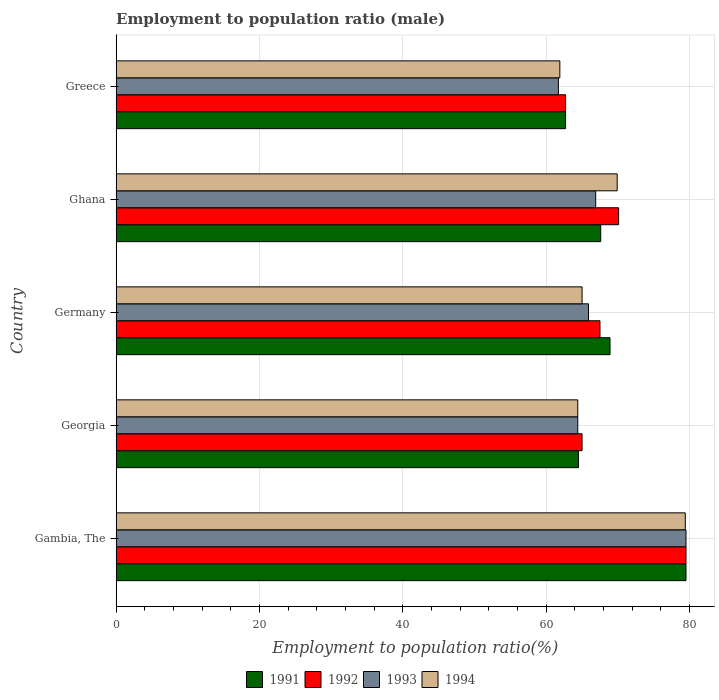How many groups of bars are there?
Your answer should be very brief. 5. Are the number of bars on each tick of the Y-axis equal?
Your answer should be very brief. Yes. How many bars are there on the 2nd tick from the top?
Offer a very short reply. 4. How many bars are there on the 1st tick from the bottom?
Ensure brevity in your answer.  4. In how many cases, is the number of bars for a given country not equal to the number of legend labels?
Keep it short and to the point. 0. What is the employment to population ratio in 1993 in Georgia?
Offer a very short reply. 64.4. Across all countries, what is the maximum employment to population ratio in 1993?
Give a very brief answer. 79.5. Across all countries, what is the minimum employment to population ratio in 1991?
Ensure brevity in your answer.  62.7. In which country was the employment to population ratio in 1991 maximum?
Offer a terse response. Gambia, The. In which country was the employment to population ratio in 1992 minimum?
Offer a very short reply. Greece. What is the total employment to population ratio in 1991 in the graph?
Your response must be concise. 343.2. What is the difference between the employment to population ratio in 1991 in Georgia and that in Germany?
Provide a short and direct response. -4.4. What is the difference between the employment to population ratio in 1993 in Georgia and the employment to population ratio in 1991 in Greece?
Your answer should be very brief. 1.7. What is the average employment to population ratio in 1992 per country?
Keep it short and to the point. 68.96. What is the difference between the employment to population ratio in 1992 and employment to population ratio in 1991 in Gambia, The?
Your response must be concise. 0. What is the ratio of the employment to population ratio in 1993 in Gambia, The to that in Germany?
Provide a short and direct response. 1.21. What is the difference between the highest and the second highest employment to population ratio in 1993?
Provide a short and direct response. 12.6. What is the difference between the highest and the lowest employment to population ratio in 1993?
Your answer should be very brief. 17.8. Is it the case that in every country, the sum of the employment to population ratio in 1993 and employment to population ratio in 1992 is greater than the sum of employment to population ratio in 1994 and employment to population ratio in 1991?
Offer a terse response. No. What does the 1st bar from the top in Gambia, The represents?
Offer a very short reply. 1994. Is it the case that in every country, the sum of the employment to population ratio in 1994 and employment to population ratio in 1992 is greater than the employment to population ratio in 1993?
Keep it short and to the point. Yes. Are all the bars in the graph horizontal?
Your answer should be very brief. Yes. How many countries are there in the graph?
Provide a short and direct response. 5. Are the values on the major ticks of X-axis written in scientific E-notation?
Provide a succinct answer. No. Does the graph contain any zero values?
Your answer should be very brief. No. Does the graph contain grids?
Make the answer very short. Yes. How many legend labels are there?
Give a very brief answer. 4. What is the title of the graph?
Offer a very short reply. Employment to population ratio (male). What is the label or title of the Y-axis?
Give a very brief answer. Country. What is the Employment to population ratio(%) of 1991 in Gambia, The?
Offer a terse response. 79.5. What is the Employment to population ratio(%) of 1992 in Gambia, The?
Provide a short and direct response. 79.5. What is the Employment to population ratio(%) in 1993 in Gambia, The?
Your answer should be compact. 79.5. What is the Employment to population ratio(%) of 1994 in Gambia, The?
Your answer should be compact. 79.4. What is the Employment to population ratio(%) in 1991 in Georgia?
Provide a succinct answer. 64.5. What is the Employment to population ratio(%) in 1992 in Georgia?
Offer a terse response. 65. What is the Employment to population ratio(%) of 1993 in Georgia?
Give a very brief answer. 64.4. What is the Employment to population ratio(%) in 1994 in Georgia?
Offer a terse response. 64.4. What is the Employment to population ratio(%) in 1991 in Germany?
Provide a short and direct response. 68.9. What is the Employment to population ratio(%) in 1992 in Germany?
Your response must be concise. 67.5. What is the Employment to population ratio(%) of 1993 in Germany?
Offer a terse response. 65.9. What is the Employment to population ratio(%) in 1994 in Germany?
Offer a very short reply. 65. What is the Employment to population ratio(%) of 1991 in Ghana?
Make the answer very short. 67.6. What is the Employment to population ratio(%) in 1992 in Ghana?
Offer a very short reply. 70.1. What is the Employment to population ratio(%) of 1993 in Ghana?
Your answer should be very brief. 66.9. What is the Employment to population ratio(%) in 1994 in Ghana?
Your response must be concise. 69.9. What is the Employment to population ratio(%) of 1991 in Greece?
Your response must be concise. 62.7. What is the Employment to population ratio(%) of 1992 in Greece?
Your answer should be very brief. 62.7. What is the Employment to population ratio(%) of 1993 in Greece?
Give a very brief answer. 61.7. What is the Employment to population ratio(%) of 1994 in Greece?
Your answer should be very brief. 61.9. Across all countries, what is the maximum Employment to population ratio(%) in 1991?
Ensure brevity in your answer.  79.5. Across all countries, what is the maximum Employment to population ratio(%) in 1992?
Your answer should be very brief. 79.5. Across all countries, what is the maximum Employment to population ratio(%) in 1993?
Keep it short and to the point. 79.5. Across all countries, what is the maximum Employment to population ratio(%) in 1994?
Your response must be concise. 79.4. Across all countries, what is the minimum Employment to population ratio(%) in 1991?
Give a very brief answer. 62.7. Across all countries, what is the minimum Employment to population ratio(%) of 1992?
Offer a very short reply. 62.7. Across all countries, what is the minimum Employment to population ratio(%) of 1993?
Keep it short and to the point. 61.7. Across all countries, what is the minimum Employment to population ratio(%) in 1994?
Keep it short and to the point. 61.9. What is the total Employment to population ratio(%) in 1991 in the graph?
Your answer should be compact. 343.2. What is the total Employment to population ratio(%) in 1992 in the graph?
Your answer should be compact. 344.8. What is the total Employment to population ratio(%) of 1993 in the graph?
Ensure brevity in your answer.  338.4. What is the total Employment to population ratio(%) in 1994 in the graph?
Keep it short and to the point. 340.6. What is the difference between the Employment to population ratio(%) of 1992 in Gambia, The and that in Georgia?
Your answer should be very brief. 14.5. What is the difference between the Employment to population ratio(%) of 1993 in Gambia, The and that in Georgia?
Offer a very short reply. 15.1. What is the difference between the Employment to population ratio(%) of 1991 in Gambia, The and that in Germany?
Make the answer very short. 10.6. What is the difference between the Employment to population ratio(%) of 1992 in Gambia, The and that in Germany?
Offer a very short reply. 12. What is the difference between the Employment to population ratio(%) of 1991 in Gambia, The and that in Ghana?
Provide a succinct answer. 11.9. What is the difference between the Employment to population ratio(%) of 1992 in Gambia, The and that in Ghana?
Ensure brevity in your answer.  9.4. What is the difference between the Employment to population ratio(%) of 1993 in Gambia, The and that in Greece?
Your response must be concise. 17.8. What is the difference between the Employment to population ratio(%) of 1991 in Georgia and that in Germany?
Make the answer very short. -4.4. What is the difference between the Employment to population ratio(%) of 1992 in Georgia and that in Germany?
Your answer should be very brief. -2.5. What is the difference between the Employment to population ratio(%) in 1993 in Georgia and that in Germany?
Make the answer very short. -1.5. What is the difference between the Employment to population ratio(%) in 1994 in Georgia and that in Germany?
Your response must be concise. -0.6. What is the difference between the Employment to population ratio(%) of 1992 in Georgia and that in Ghana?
Offer a very short reply. -5.1. What is the difference between the Employment to population ratio(%) in 1994 in Georgia and that in Ghana?
Offer a terse response. -5.5. What is the difference between the Employment to population ratio(%) in 1992 in Georgia and that in Greece?
Make the answer very short. 2.3. What is the difference between the Employment to population ratio(%) in 1994 in Georgia and that in Greece?
Give a very brief answer. 2.5. What is the difference between the Employment to population ratio(%) of 1991 in Germany and that in Ghana?
Provide a succinct answer. 1.3. What is the difference between the Employment to population ratio(%) of 1992 in Germany and that in Ghana?
Your answer should be very brief. -2.6. What is the difference between the Employment to population ratio(%) in 1992 in Germany and that in Greece?
Provide a short and direct response. 4.8. What is the difference between the Employment to population ratio(%) of 1993 in Germany and that in Greece?
Provide a succinct answer. 4.2. What is the difference between the Employment to population ratio(%) of 1994 in Germany and that in Greece?
Provide a succinct answer. 3.1. What is the difference between the Employment to population ratio(%) in 1992 in Ghana and that in Greece?
Provide a short and direct response. 7.4. What is the difference between the Employment to population ratio(%) of 1993 in Ghana and that in Greece?
Give a very brief answer. 5.2. What is the difference between the Employment to population ratio(%) of 1994 in Ghana and that in Greece?
Provide a succinct answer. 8. What is the difference between the Employment to population ratio(%) in 1991 in Gambia, The and the Employment to population ratio(%) in 1992 in Georgia?
Your answer should be compact. 14.5. What is the difference between the Employment to population ratio(%) of 1992 in Gambia, The and the Employment to population ratio(%) of 1994 in Georgia?
Your response must be concise. 15.1. What is the difference between the Employment to population ratio(%) in 1992 in Gambia, The and the Employment to population ratio(%) in 1993 in Germany?
Provide a succinct answer. 13.6. What is the difference between the Employment to population ratio(%) of 1992 in Gambia, The and the Employment to population ratio(%) of 1994 in Germany?
Your answer should be very brief. 14.5. What is the difference between the Employment to population ratio(%) in 1993 in Gambia, The and the Employment to population ratio(%) in 1994 in Germany?
Offer a very short reply. 14.5. What is the difference between the Employment to population ratio(%) of 1991 in Gambia, The and the Employment to population ratio(%) of 1992 in Ghana?
Provide a short and direct response. 9.4. What is the difference between the Employment to population ratio(%) of 1991 in Gambia, The and the Employment to population ratio(%) of 1994 in Ghana?
Provide a short and direct response. 9.6. What is the difference between the Employment to population ratio(%) in 1992 in Gambia, The and the Employment to population ratio(%) in 1994 in Ghana?
Ensure brevity in your answer.  9.6. What is the difference between the Employment to population ratio(%) in 1993 in Gambia, The and the Employment to population ratio(%) in 1994 in Ghana?
Offer a terse response. 9.6. What is the difference between the Employment to population ratio(%) of 1991 in Gambia, The and the Employment to population ratio(%) of 1994 in Greece?
Make the answer very short. 17.6. What is the difference between the Employment to population ratio(%) of 1992 in Gambia, The and the Employment to population ratio(%) of 1993 in Greece?
Your answer should be very brief. 17.8. What is the difference between the Employment to population ratio(%) of 1991 in Georgia and the Employment to population ratio(%) of 1992 in Germany?
Your answer should be compact. -3. What is the difference between the Employment to population ratio(%) of 1991 in Georgia and the Employment to population ratio(%) of 1994 in Germany?
Your answer should be compact. -0.5. What is the difference between the Employment to population ratio(%) in 1992 in Georgia and the Employment to population ratio(%) in 1994 in Germany?
Offer a very short reply. 0. What is the difference between the Employment to population ratio(%) of 1993 in Georgia and the Employment to population ratio(%) of 1994 in Germany?
Ensure brevity in your answer.  -0.6. What is the difference between the Employment to population ratio(%) of 1991 in Georgia and the Employment to population ratio(%) of 1992 in Ghana?
Your answer should be compact. -5.6. What is the difference between the Employment to population ratio(%) of 1991 in Georgia and the Employment to population ratio(%) of 1994 in Ghana?
Keep it short and to the point. -5.4. What is the difference between the Employment to population ratio(%) of 1993 in Georgia and the Employment to population ratio(%) of 1994 in Ghana?
Provide a succinct answer. -5.5. What is the difference between the Employment to population ratio(%) of 1991 in Georgia and the Employment to population ratio(%) of 1992 in Greece?
Your answer should be compact. 1.8. What is the difference between the Employment to population ratio(%) in 1991 in Germany and the Employment to population ratio(%) in 1992 in Ghana?
Provide a succinct answer. -1.2. What is the difference between the Employment to population ratio(%) in 1992 in Germany and the Employment to population ratio(%) in 1993 in Ghana?
Your response must be concise. 0.6. What is the difference between the Employment to population ratio(%) of 1991 in Germany and the Employment to population ratio(%) of 1992 in Greece?
Provide a succinct answer. 6.2. What is the difference between the Employment to population ratio(%) of 1991 in Germany and the Employment to population ratio(%) of 1993 in Greece?
Provide a succinct answer. 7.2. What is the difference between the Employment to population ratio(%) of 1991 in Germany and the Employment to population ratio(%) of 1994 in Greece?
Offer a terse response. 7. What is the difference between the Employment to population ratio(%) of 1992 in Germany and the Employment to population ratio(%) of 1993 in Greece?
Your answer should be compact. 5.8. What is the difference between the Employment to population ratio(%) in 1992 in Germany and the Employment to population ratio(%) in 1994 in Greece?
Your response must be concise. 5.6. What is the difference between the Employment to population ratio(%) in 1993 in Germany and the Employment to population ratio(%) in 1994 in Greece?
Make the answer very short. 4. What is the difference between the Employment to population ratio(%) of 1991 in Ghana and the Employment to population ratio(%) of 1994 in Greece?
Ensure brevity in your answer.  5.7. What is the difference between the Employment to population ratio(%) in 1992 in Ghana and the Employment to population ratio(%) in 1993 in Greece?
Your answer should be compact. 8.4. What is the difference between the Employment to population ratio(%) of 1992 in Ghana and the Employment to population ratio(%) of 1994 in Greece?
Offer a very short reply. 8.2. What is the average Employment to population ratio(%) in 1991 per country?
Give a very brief answer. 68.64. What is the average Employment to population ratio(%) in 1992 per country?
Offer a terse response. 68.96. What is the average Employment to population ratio(%) in 1993 per country?
Make the answer very short. 67.68. What is the average Employment to population ratio(%) in 1994 per country?
Offer a very short reply. 68.12. What is the difference between the Employment to population ratio(%) in 1991 and Employment to population ratio(%) in 1993 in Gambia, The?
Ensure brevity in your answer.  0. What is the difference between the Employment to population ratio(%) of 1993 and Employment to population ratio(%) of 1994 in Gambia, The?
Keep it short and to the point. 0.1. What is the difference between the Employment to population ratio(%) of 1991 and Employment to population ratio(%) of 1992 in Georgia?
Make the answer very short. -0.5. What is the difference between the Employment to population ratio(%) of 1991 and Employment to population ratio(%) of 1994 in Georgia?
Ensure brevity in your answer.  0.1. What is the difference between the Employment to population ratio(%) in 1992 and Employment to population ratio(%) in 1994 in Georgia?
Your answer should be very brief. 0.6. What is the difference between the Employment to population ratio(%) of 1993 and Employment to population ratio(%) of 1994 in Georgia?
Make the answer very short. 0. What is the difference between the Employment to population ratio(%) of 1991 and Employment to population ratio(%) of 1992 in Germany?
Your response must be concise. 1.4. What is the difference between the Employment to population ratio(%) of 1991 and Employment to population ratio(%) of 1993 in Germany?
Ensure brevity in your answer.  3. What is the difference between the Employment to population ratio(%) of 1991 and Employment to population ratio(%) of 1994 in Germany?
Provide a short and direct response. 3.9. What is the difference between the Employment to population ratio(%) in 1993 and Employment to population ratio(%) in 1994 in Germany?
Your response must be concise. 0.9. What is the difference between the Employment to population ratio(%) in 1991 and Employment to population ratio(%) in 1992 in Ghana?
Your response must be concise. -2.5. What is the difference between the Employment to population ratio(%) in 1992 and Employment to population ratio(%) in 1993 in Ghana?
Offer a very short reply. 3.2. What is the difference between the Employment to population ratio(%) in 1991 and Employment to population ratio(%) in 1992 in Greece?
Offer a terse response. 0. What is the difference between the Employment to population ratio(%) in 1991 and Employment to population ratio(%) in 1993 in Greece?
Offer a very short reply. 1. What is the difference between the Employment to population ratio(%) in 1992 and Employment to population ratio(%) in 1994 in Greece?
Keep it short and to the point. 0.8. What is the difference between the Employment to population ratio(%) of 1993 and Employment to population ratio(%) of 1994 in Greece?
Your answer should be compact. -0.2. What is the ratio of the Employment to population ratio(%) of 1991 in Gambia, The to that in Georgia?
Offer a very short reply. 1.23. What is the ratio of the Employment to population ratio(%) in 1992 in Gambia, The to that in Georgia?
Your response must be concise. 1.22. What is the ratio of the Employment to population ratio(%) of 1993 in Gambia, The to that in Georgia?
Give a very brief answer. 1.23. What is the ratio of the Employment to population ratio(%) of 1994 in Gambia, The to that in Georgia?
Make the answer very short. 1.23. What is the ratio of the Employment to population ratio(%) of 1991 in Gambia, The to that in Germany?
Make the answer very short. 1.15. What is the ratio of the Employment to population ratio(%) in 1992 in Gambia, The to that in Germany?
Give a very brief answer. 1.18. What is the ratio of the Employment to population ratio(%) of 1993 in Gambia, The to that in Germany?
Your response must be concise. 1.21. What is the ratio of the Employment to population ratio(%) of 1994 in Gambia, The to that in Germany?
Give a very brief answer. 1.22. What is the ratio of the Employment to population ratio(%) in 1991 in Gambia, The to that in Ghana?
Your answer should be very brief. 1.18. What is the ratio of the Employment to population ratio(%) of 1992 in Gambia, The to that in Ghana?
Offer a very short reply. 1.13. What is the ratio of the Employment to population ratio(%) of 1993 in Gambia, The to that in Ghana?
Keep it short and to the point. 1.19. What is the ratio of the Employment to population ratio(%) of 1994 in Gambia, The to that in Ghana?
Provide a short and direct response. 1.14. What is the ratio of the Employment to population ratio(%) in 1991 in Gambia, The to that in Greece?
Your response must be concise. 1.27. What is the ratio of the Employment to population ratio(%) in 1992 in Gambia, The to that in Greece?
Ensure brevity in your answer.  1.27. What is the ratio of the Employment to population ratio(%) of 1993 in Gambia, The to that in Greece?
Your response must be concise. 1.29. What is the ratio of the Employment to population ratio(%) of 1994 in Gambia, The to that in Greece?
Make the answer very short. 1.28. What is the ratio of the Employment to population ratio(%) of 1991 in Georgia to that in Germany?
Offer a terse response. 0.94. What is the ratio of the Employment to population ratio(%) in 1993 in Georgia to that in Germany?
Keep it short and to the point. 0.98. What is the ratio of the Employment to population ratio(%) of 1991 in Georgia to that in Ghana?
Keep it short and to the point. 0.95. What is the ratio of the Employment to population ratio(%) in 1992 in Georgia to that in Ghana?
Give a very brief answer. 0.93. What is the ratio of the Employment to population ratio(%) of 1993 in Georgia to that in Ghana?
Give a very brief answer. 0.96. What is the ratio of the Employment to population ratio(%) in 1994 in Georgia to that in Ghana?
Provide a short and direct response. 0.92. What is the ratio of the Employment to population ratio(%) of 1991 in Georgia to that in Greece?
Ensure brevity in your answer.  1.03. What is the ratio of the Employment to population ratio(%) in 1992 in Georgia to that in Greece?
Your answer should be very brief. 1.04. What is the ratio of the Employment to population ratio(%) in 1993 in Georgia to that in Greece?
Keep it short and to the point. 1.04. What is the ratio of the Employment to population ratio(%) of 1994 in Georgia to that in Greece?
Your answer should be compact. 1.04. What is the ratio of the Employment to population ratio(%) of 1991 in Germany to that in Ghana?
Provide a succinct answer. 1.02. What is the ratio of the Employment to population ratio(%) in 1992 in Germany to that in Ghana?
Give a very brief answer. 0.96. What is the ratio of the Employment to population ratio(%) in 1993 in Germany to that in Ghana?
Your answer should be compact. 0.99. What is the ratio of the Employment to population ratio(%) in 1994 in Germany to that in Ghana?
Your response must be concise. 0.93. What is the ratio of the Employment to population ratio(%) of 1991 in Germany to that in Greece?
Your response must be concise. 1.1. What is the ratio of the Employment to population ratio(%) in 1992 in Germany to that in Greece?
Keep it short and to the point. 1.08. What is the ratio of the Employment to population ratio(%) of 1993 in Germany to that in Greece?
Keep it short and to the point. 1.07. What is the ratio of the Employment to population ratio(%) in 1994 in Germany to that in Greece?
Offer a very short reply. 1.05. What is the ratio of the Employment to population ratio(%) of 1991 in Ghana to that in Greece?
Give a very brief answer. 1.08. What is the ratio of the Employment to population ratio(%) of 1992 in Ghana to that in Greece?
Provide a short and direct response. 1.12. What is the ratio of the Employment to population ratio(%) in 1993 in Ghana to that in Greece?
Ensure brevity in your answer.  1.08. What is the ratio of the Employment to population ratio(%) of 1994 in Ghana to that in Greece?
Your answer should be very brief. 1.13. What is the difference between the highest and the second highest Employment to population ratio(%) in 1991?
Offer a very short reply. 10.6. What is the difference between the highest and the lowest Employment to population ratio(%) in 1991?
Your answer should be compact. 16.8. What is the difference between the highest and the lowest Employment to population ratio(%) of 1993?
Ensure brevity in your answer.  17.8. What is the difference between the highest and the lowest Employment to population ratio(%) of 1994?
Provide a short and direct response. 17.5. 